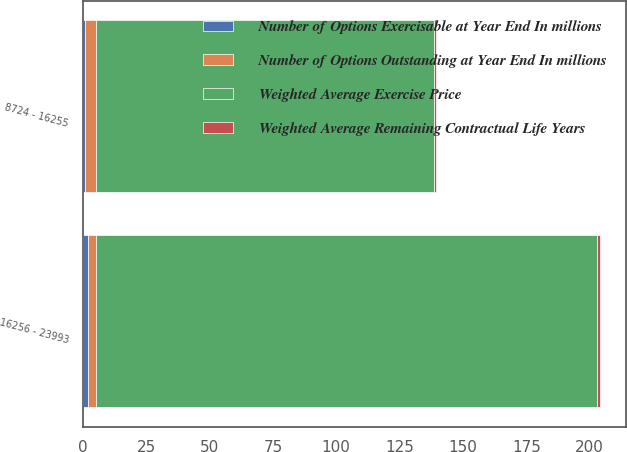Convert chart to OTSL. <chart><loc_0><loc_0><loc_500><loc_500><stacked_bar_chart><ecel><fcel>8724 - 16255<fcel>16256 - 23993<nl><fcel>Number of Options Exercisable at Year End In millions<fcel>1<fcel>2<nl><fcel>Number of Options Outstanding at Year End In millions<fcel>4<fcel>3<nl><fcel>Weighted Average Exercise Price<fcel>133.54<fcel>197.98<nl><fcel>Weighted Average Remaining Contractual Life Years<fcel>1<fcel>1<nl></chart> 